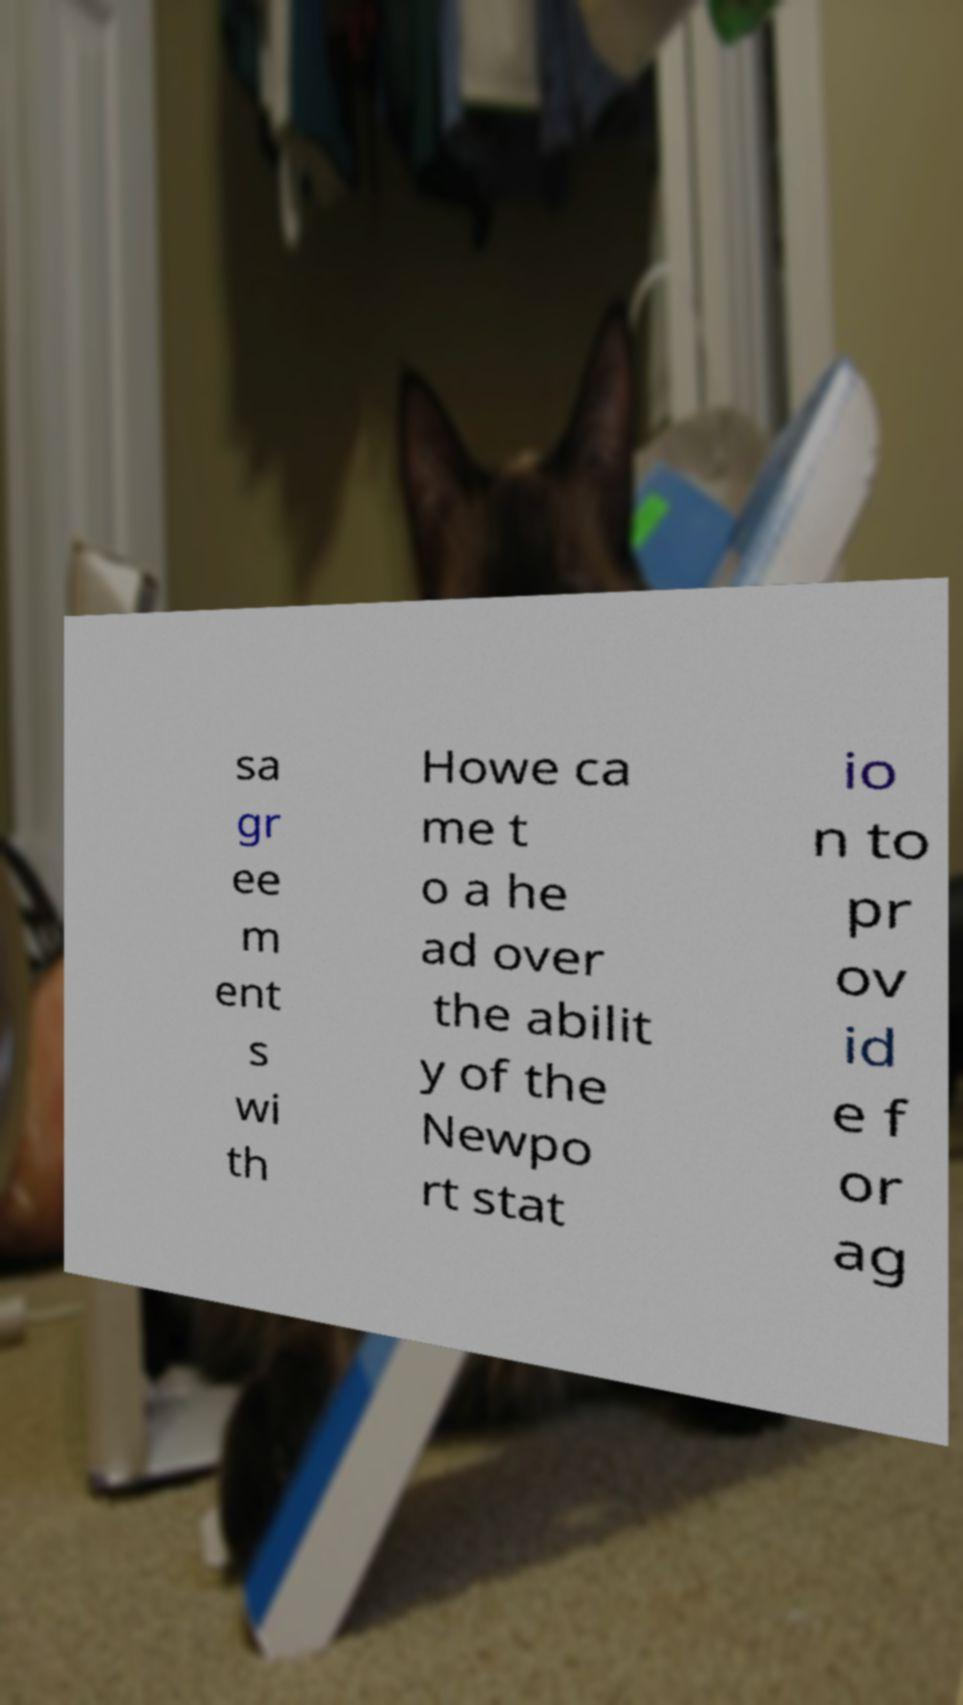Could you extract and type out the text from this image? sa gr ee m ent s wi th Howe ca me t o a he ad over the abilit y of the Newpo rt stat io n to pr ov id e f or ag 